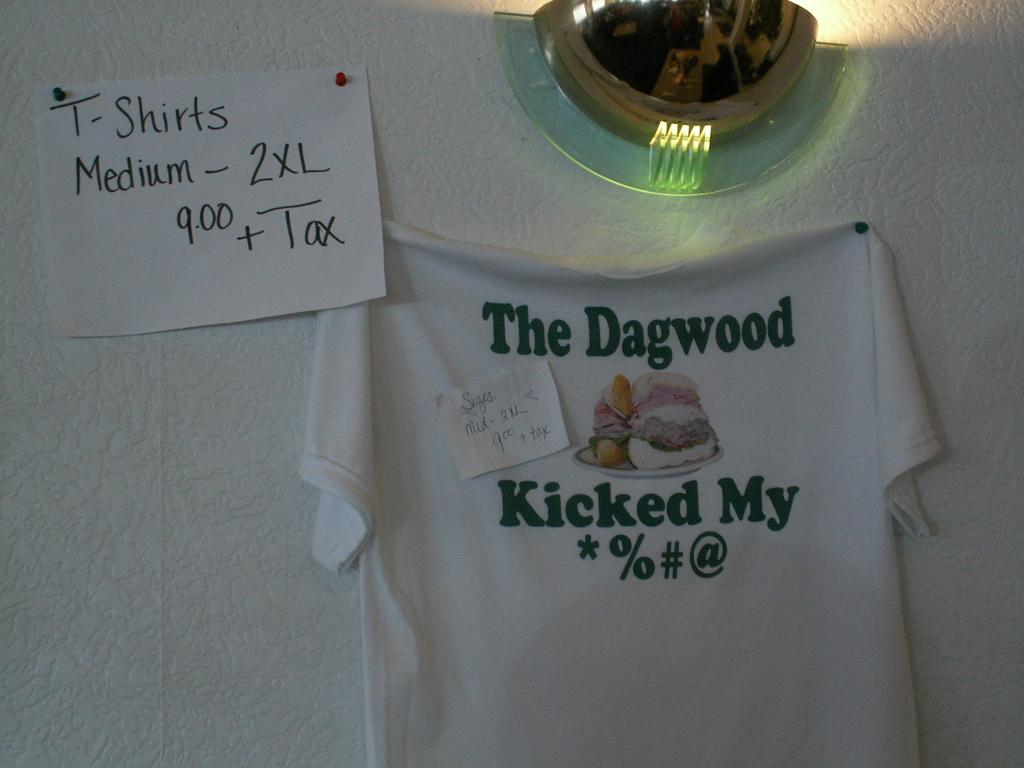What is hanging on the wall in the image? There is a shirt hanged on the wall in the image. What is attached to the shirt on the wall? A small piece of paper is pasted on the shirt. What else can be seen on the wall in the image? There is a paper on the wall. Can you describe the lighting in the image? A ceiling light is present on the wall. What type of bottle is sitting on the shirt in the image? There is no bottle present on the shirt or in the image. Can you describe the snail crawling on the paper in the image? There is no snail present on the paper or in the image. 